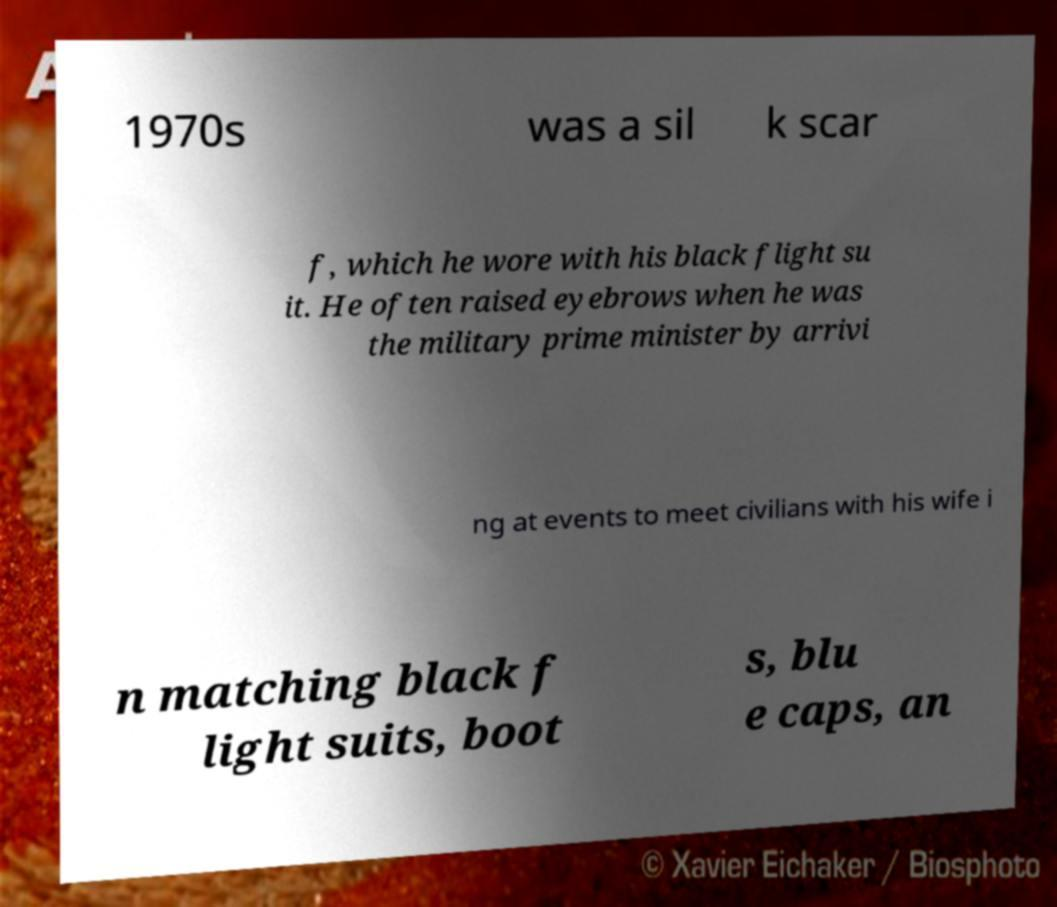What messages or text are displayed in this image? I need them in a readable, typed format. 1970s was a sil k scar f, which he wore with his black flight su it. He often raised eyebrows when he was the military prime minister by arrivi ng at events to meet civilians with his wife i n matching black f light suits, boot s, blu e caps, an 